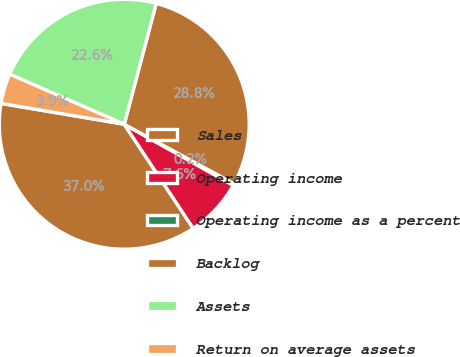<chart> <loc_0><loc_0><loc_500><loc_500><pie_chart><fcel>Sales<fcel>Operating income<fcel>Operating income as a percent<fcel>Backlog<fcel>Assets<fcel>Return on average assets<nl><fcel>36.97%<fcel>7.57%<fcel>0.22%<fcel>28.79%<fcel>22.56%<fcel>3.89%<nl></chart> 